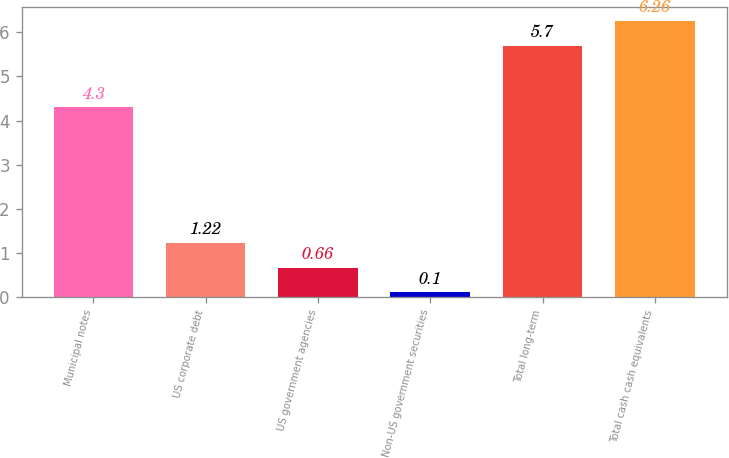Convert chart. <chart><loc_0><loc_0><loc_500><loc_500><bar_chart><fcel>Municipal notes<fcel>US corporate debt<fcel>US government agencies<fcel>Non-US government securities<fcel>Total long-term<fcel>Total cash cash equivalents<nl><fcel>4.3<fcel>1.22<fcel>0.66<fcel>0.1<fcel>5.7<fcel>6.26<nl></chart> 